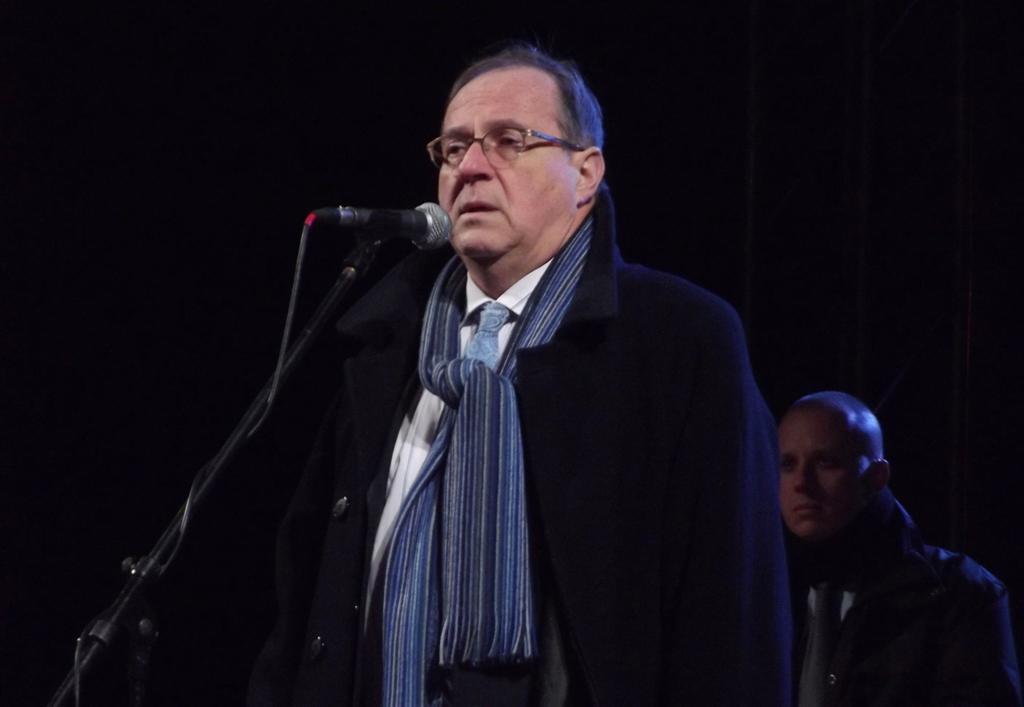Can you describe this image briefly? The man is highlighted in this picture. This man wore scarf and black jacket. He is standing in-front of the mic. This is a mic holder. Backside of this man there is a another person standing. This person wore spectacles. 